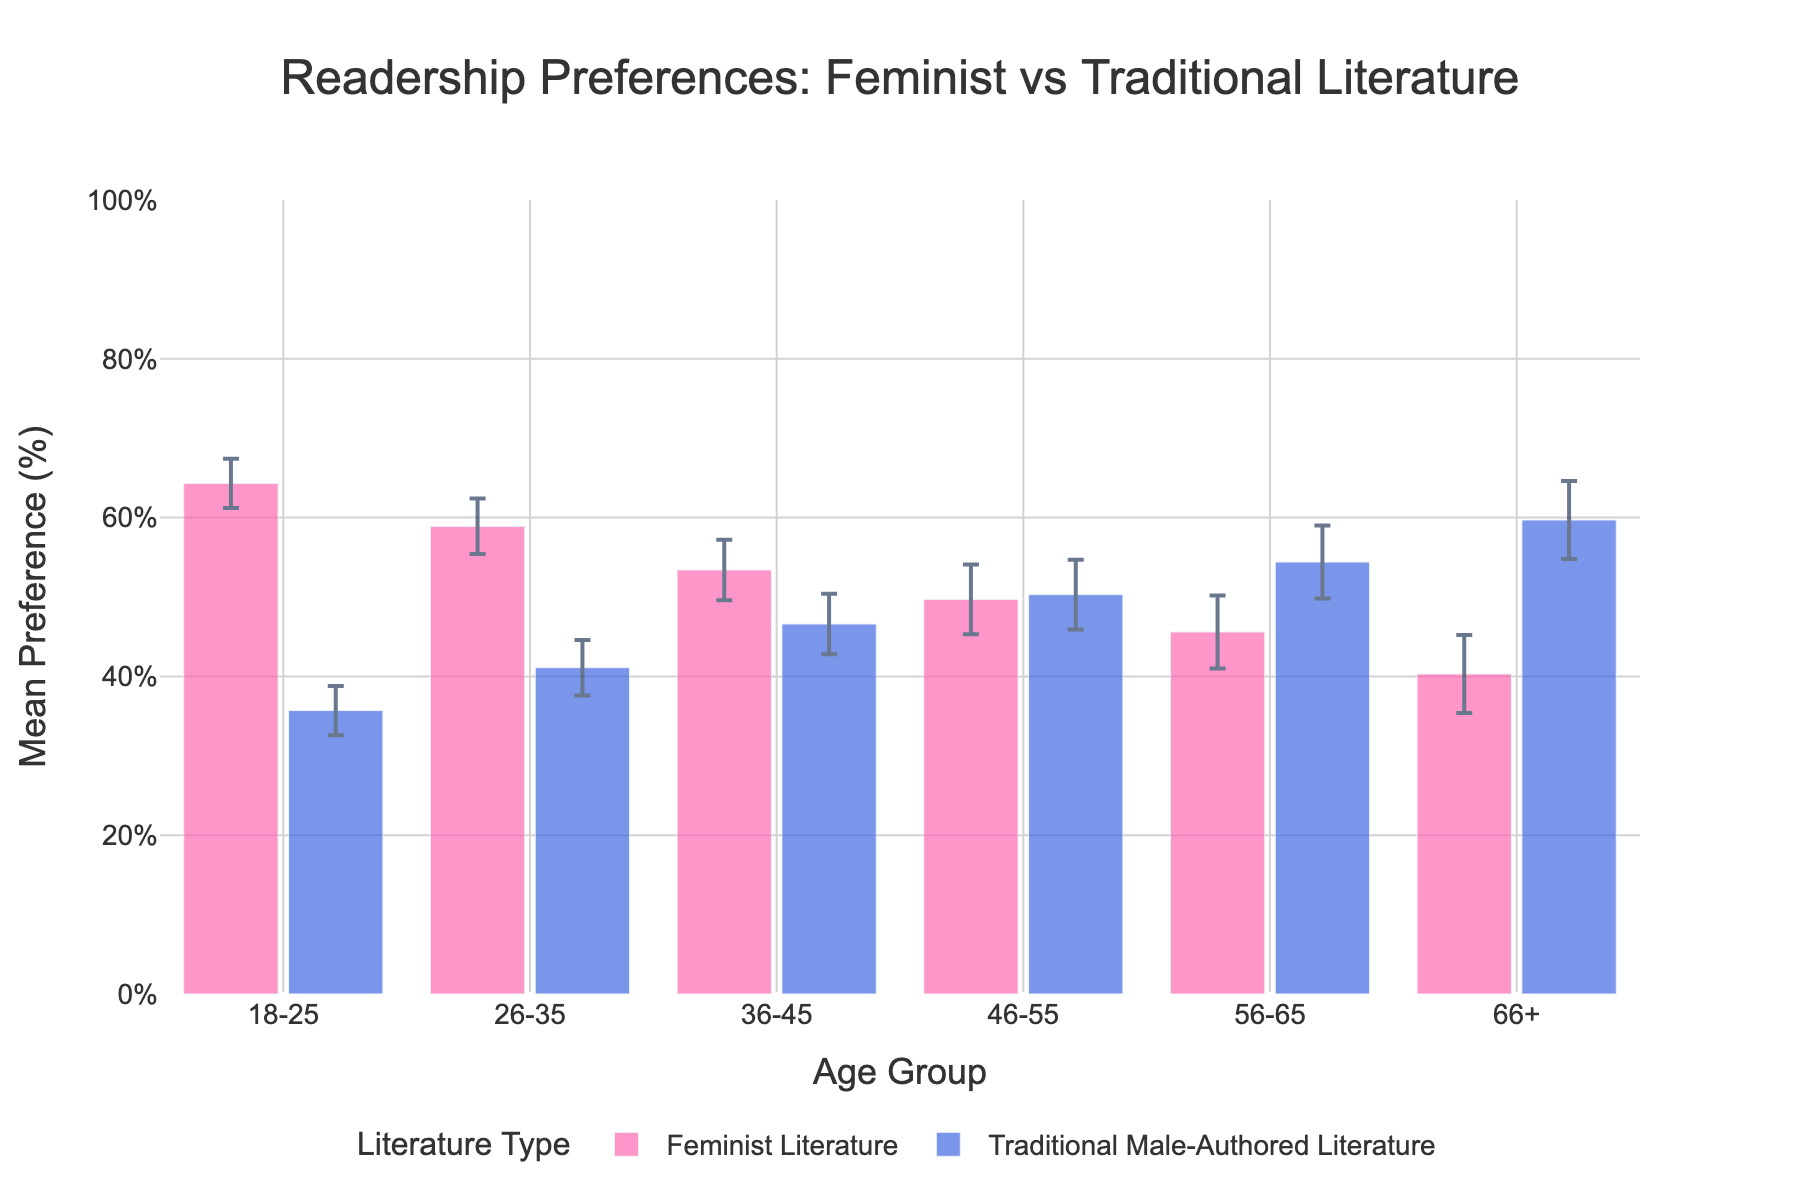What is the title of the plot? The title is displayed at the top of the plot. It provides an overview of what the plot is about by summarizing the main data being observed.
Answer: Readership Preferences: Feminist vs Traditional Literature Which age group has the highest mean preference for Traditional Male-Authored Literature? Look at the bars representing Traditional Male-Authored Literature and identify the one with the maximum height. The highest bar corresponds to the age group 66+.
Answer: 66+ What is the mean preference for Feminist Literature among the 18-25 age group? Find the bar representing the 18-25 age group's preference for Feminist Literature and read the value on the y-axis.
Answer: 64.3% What is the difference in mean preference for Feminist Literature between the 18-25 and 66+ age groups? Subtract the mean preference of the 66+ age group from the mean preference of the 18-25 age group for Feminist Literature. 64.3% - 40.3% = 24%
Answer: 24% In which age group are the mean preferences for Feminist and Traditional Male-Authored Literature most similar? Look for the age group where the heights of the two bars are closest. The closest bars are within the 46-55 age group.
Answer: 46-55 What is the confidence interval for the mean preference of Traditional Male-Authored Literature in the 26-35 age group? Identify the error bars for the 26-35 age group's Traditional Male-Authored Literature preference and read the upper and lower bounds. The lower bound is 37.6%, and the upper bound is 44.6%.
Answer: 37.6% to 44.6% Which age group shows the largest error margin for Traditional Male-Authored Literature, and what is the margin? Calculate the error margins (upper CI - lower CI) for Traditional Male-Authored Literature across all age groups and find the maximum. The age group 56-65 has the largest error margin: 59.0% - 49.8% = 9.2%.
Answer: 56-65, 9.2% What is the combined mean preference for both literature types in the 36-45 age group? Sum the mean preferences for Feminist Literature (53.4%) and Traditional Male-Authored Literature (46.6%) in the 36-45 age group. 53.4% + 46.6% = 100%.
Answer: 100% Which age group shows a reversal in preference, favoring Traditional Male-Authored Literature over Feminist Literature? Identify the age group where the bar for Traditional Male-Authored Literature is higher than the bar for Feminist Literature. This occurs in the 56-65 and 66+ age groups.
Answer: 56-65 and 66+ What is the overall trend in mean preference for Traditional Male-Authored Literature as age increases? Observe the heights of the bars for Traditional Male-Authored Literature across increasing age groups. The heights increase, indicating that preference generally increases with age.
Answer: Increases 